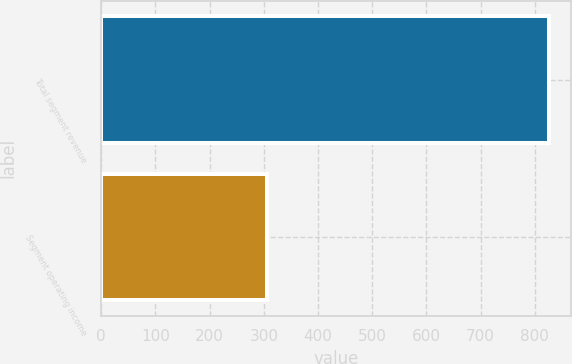Convert chart to OTSL. <chart><loc_0><loc_0><loc_500><loc_500><bar_chart><fcel>Total segment revenue<fcel>Segment operating income<nl><fcel>826<fcel>306<nl></chart> 